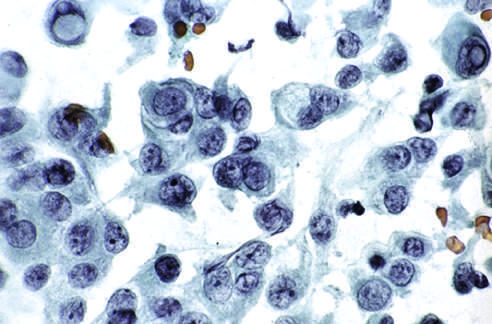re characteristic intranuclear inclusions visible in some of the aspirated cells?
Answer the question using a single word or phrase. Yes 